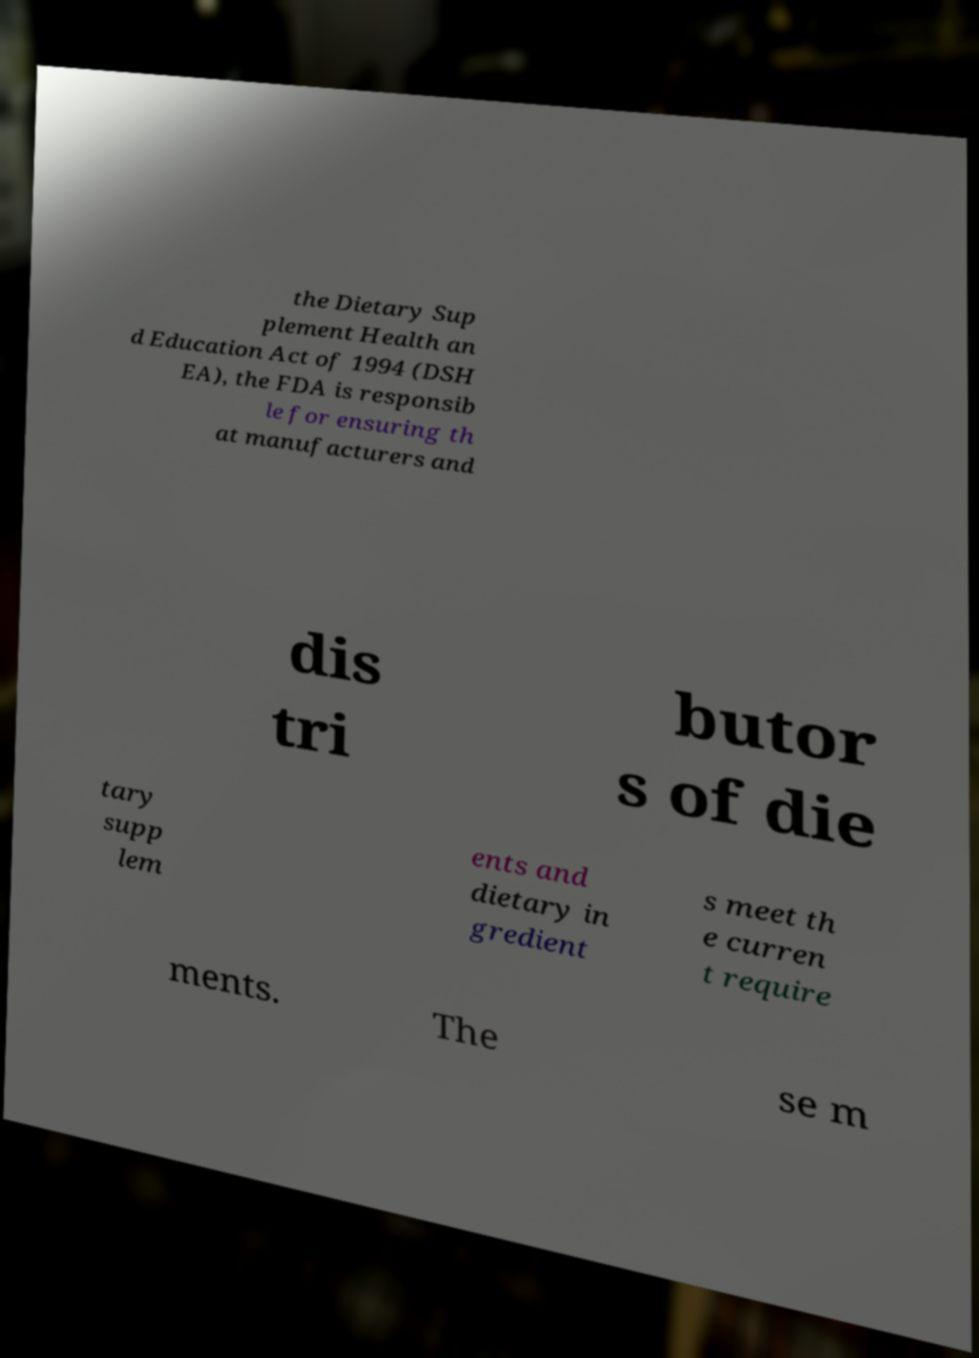Could you assist in decoding the text presented in this image and type it out clearly? the Dietary Sup plement Health an d Education Act of 1994 (DSH EA), the FDA is responsib le for ensuring th at manufacturers and dis tri butor s of die tary supp lem ents and dietary in gredient s meet th e curren t require ments. The se m 